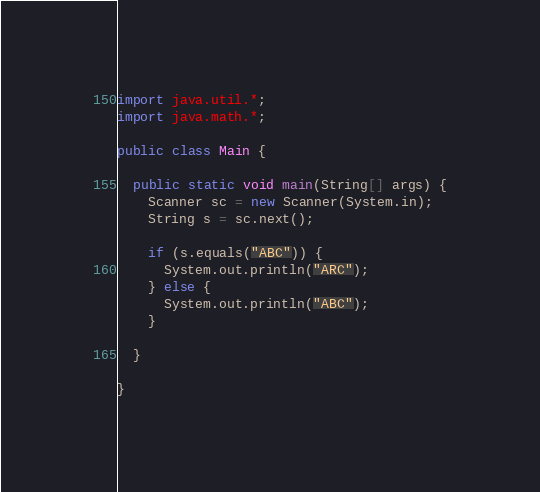Convert code to text. <code><loc_0><loc_0><loc_500><loc_500><_Java_>import java.util.*;
import java.math.*;

public class Main {

  public static void main(String[] args) {
    Scanner sc = new Scanner(System.in);
    String s = sc.next();

    if (s.equals("ABC")) {
      System.out.println("ARC");
    } else {
      System.out.println("ABC");
    }

  }

}
</code> 